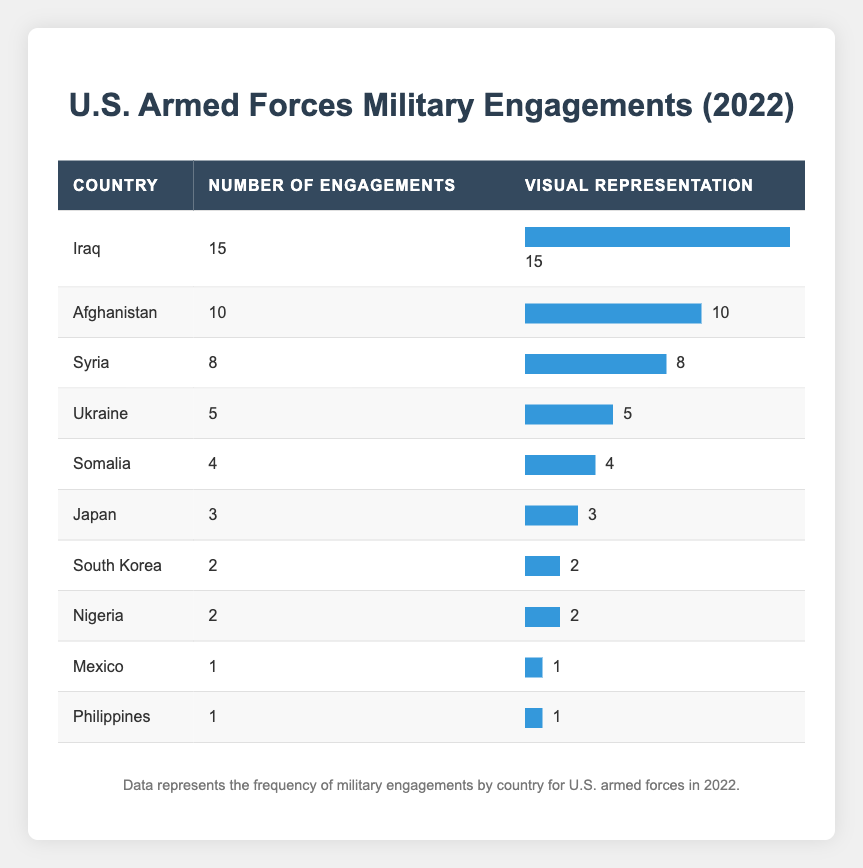What country had the highest number of military engagements? Referring to the table, Iraq has the highest number of military engagements listed, with a total of 15 engagements.
Answer: Iraq How many engagements were there in Afghanistan? The table specifies that there were 10 military engagements involving U.S. armed forces in Afghanistan.
Answer: 10 What is the total number of military engagements listed for U.S. armed forces across all countries? To find the total, add the number of engagements for each country: 15 (Iraq) + 10 (Afghanistan) + 8 (Syria) + 5 (Ukraine) + 4 (Somalia) + 3 (Japan) + 2 (South Korea) + 2 (Nigeria) + 1 (Mexico) + 1 (Philippines) = 51.
Answer: 51 Did the U.S. have more military engagements in Somalia than in the Philippines? According to the table, Somalia had 4 engagements while the Philippines had 1. Therefore, yes, U.S. armed forces had more engagements in Somalia.
Answer: Yes What is the average number of military engagements per country for the U.S.? There are 10 countries listed with a total of 51 engagements. To find the average, divide total engagements by the number of countries: 51/10 = 5.1 engagements per country.
Answer: 5.1 How many engagements did U.S. armed forces conduct in Ukraine and Syria combined? The engagements in Ukraine are 5 and in Syria are 8. Combining these gives: 5 (Ukraine) + 8 (Syria) = 13 engagements.
Answer: 13 Which country had the fewest military engagements? The table shows that both Mexico and the Philippines each had only 1 engagement, which is the lowest among all listed countries.
Answer: Mexico and Philippines Is it true that U.S. armed forces had more engagements in Japan than in South Korea? Japan had 3 engagements while South Korea had 2. Since 3 is greater than 2, this statement is true.
Answer: Yes Which country had exactly 2 military engagements? The table indicates that both South Korea and Nigeria had 2 engagements each.
Answer: South Korea and Nigeria 